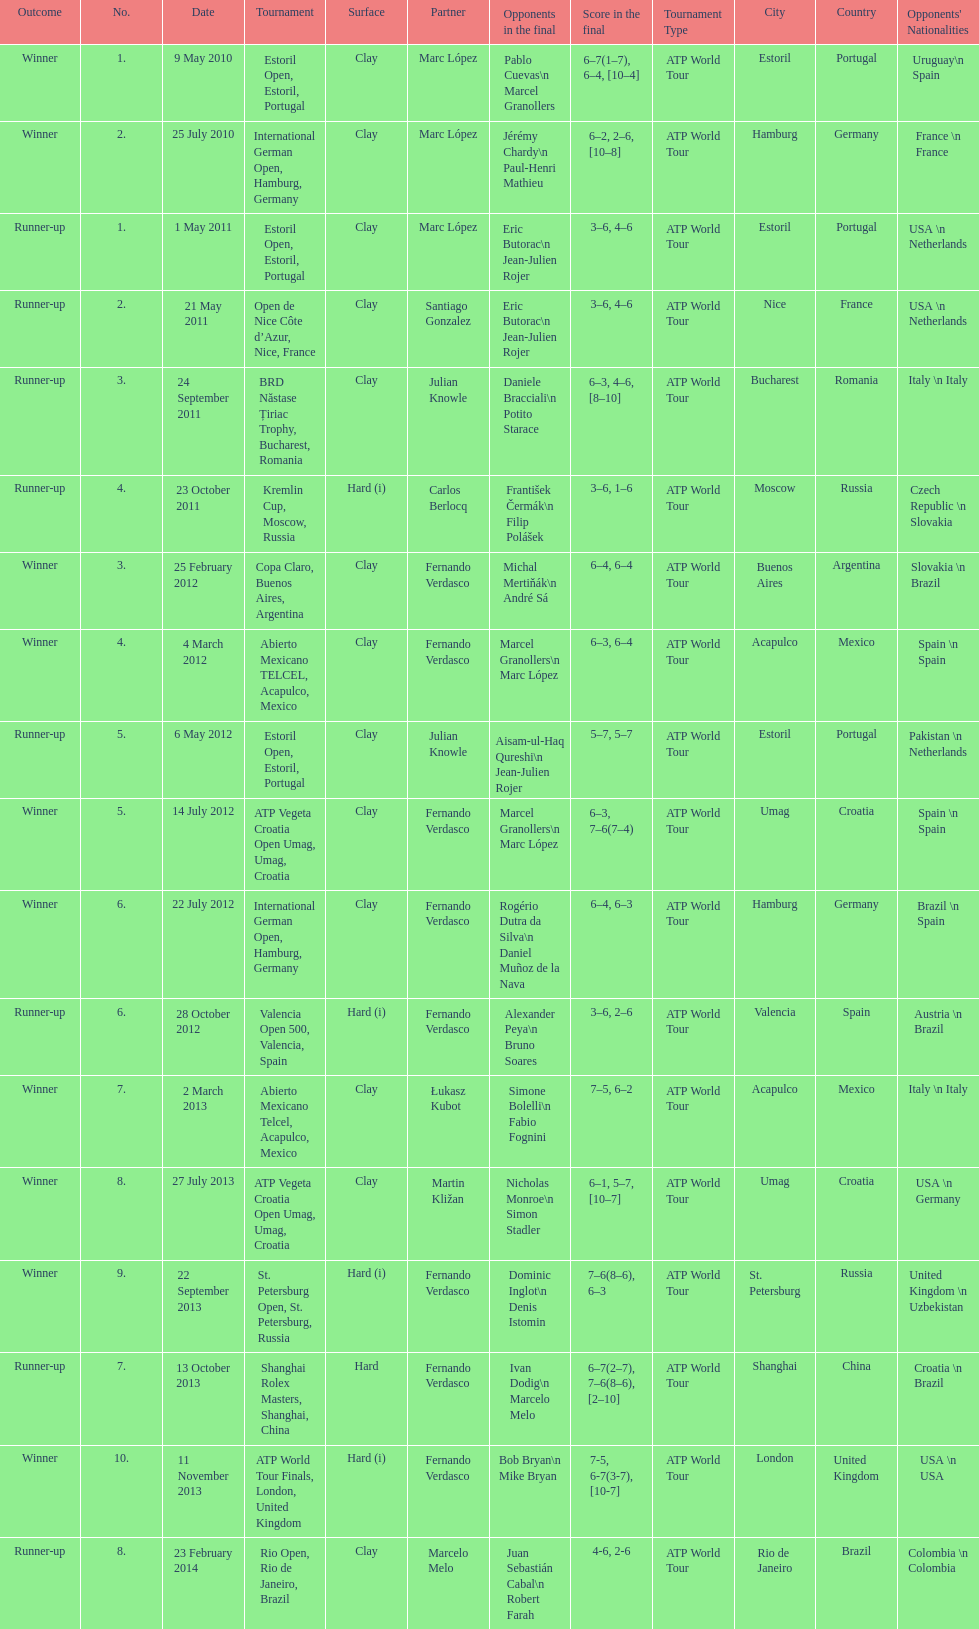Who won both the st.petersburg open and the atp world tour finals? Fernando Verdasco. 